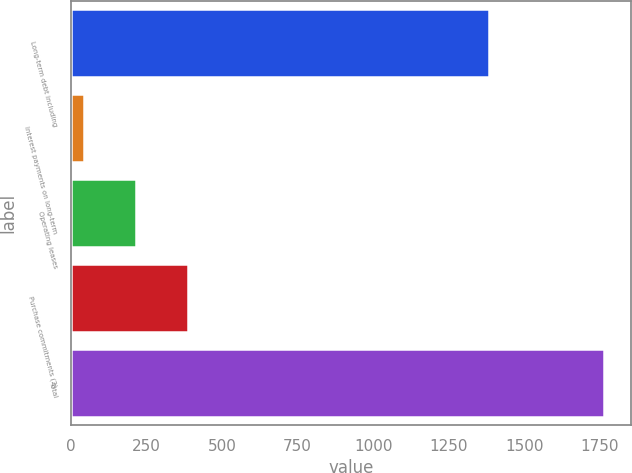Convert chart. <chart><loc_0><loc_0><loc_500><loc_500><bar_chart><fcel>Long-term debt including<fcel>Interest payments on long-term<fcel>Operating leases<fcel>Purchase commitments (2)<fcel>Total<nl><fcel>1382.7<fcel>43.9<fcel>215.98<fcel>388.06<fcel>1764.7<nl></chart> 